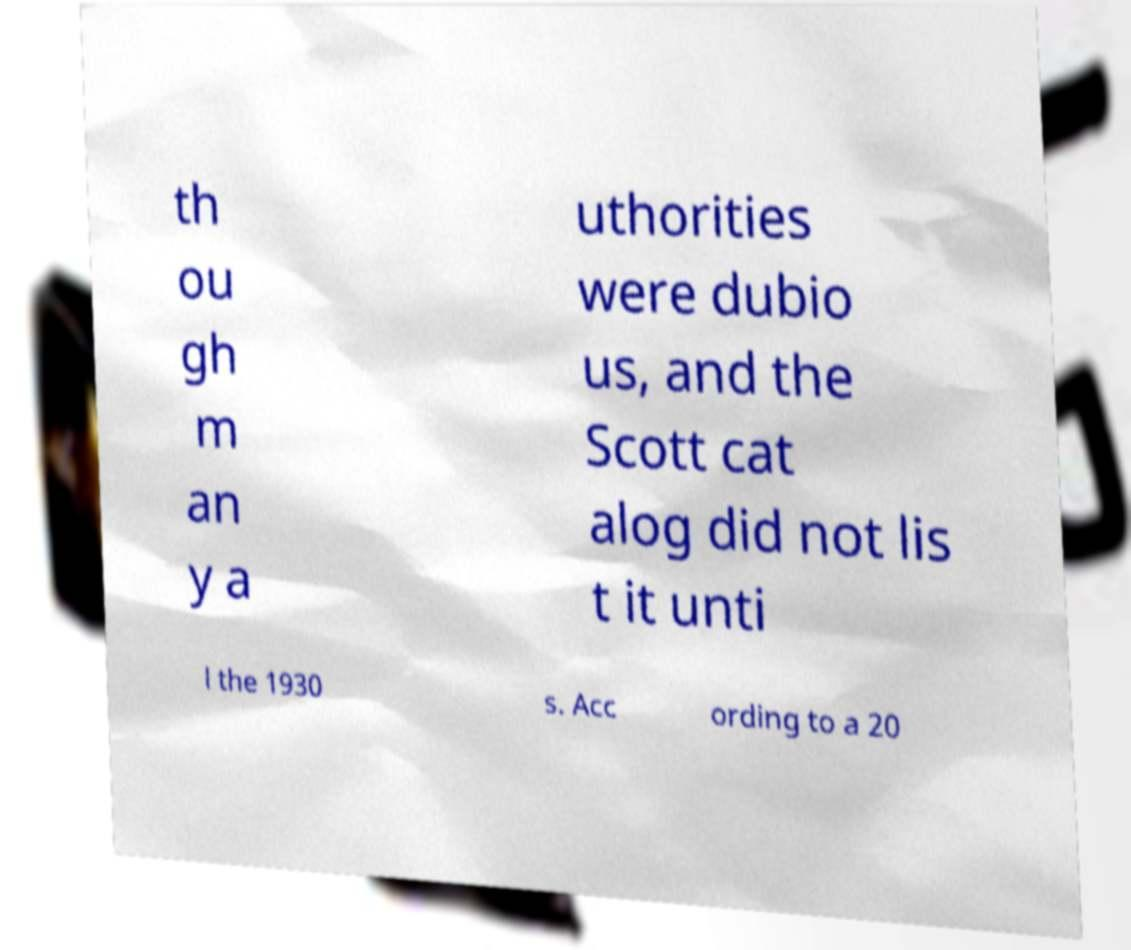Could you assist in decoding the text presented in this image and type it out clearly? th ou gh m an y a uthorities were dubio us, and the Scott cat alog did not lis t it unti l the 1930 s. Acc ording to a 20 